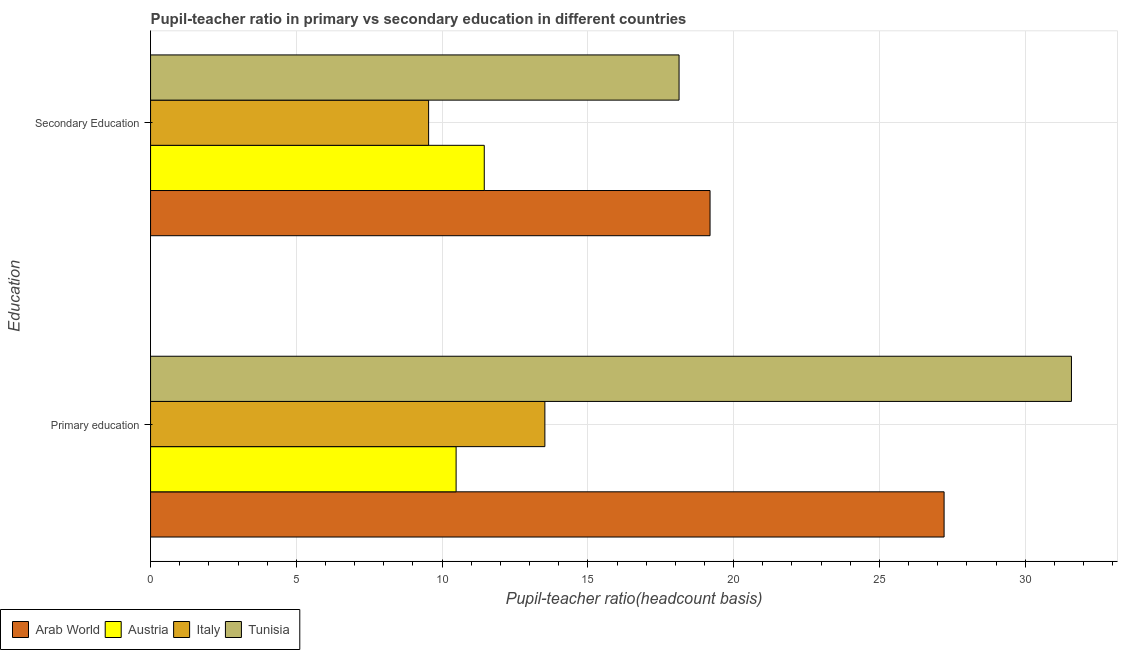How many different coloured bars are there?
Your answer should be very brief. 4. How many groups of bars are there?
Ensure brevity in your answer.  2. Are the number of bars per tick equal to the number of legend labels?
Provide a succinct answer. Yes. Are the number of bars on each tick of the Y-axis equal?
Make the answer very short. Yes. What is the label of the 2nd group of bars from the top?
Ensure brevity in your answer.  Primary education. What is the pupil-teacher ratio in primary education in Arab World?
Offer a terse response. 27.22. Across all countries, what is the maximum pupil teacher ratio on secondary education?
Offer a very short reply. 19.19. Across all countries, what is the minimum pupil-teacher ratio in primary education?
Provide a succinct answer. 10.48. In which country was the pupil teacher ratio on secondary education maximum?
Keep it short and to the point. Arab World. In which country was the pupil-teacher ratio in primary education minimum?
Your answer should be very brief. Austria. What is the total pupil-teacher ratio in primary education in the graph?
Offer a very short reply. 82.81. What is the difference between the pupil-teacher ratio in primary education in Austria and that in Tunisia?
Your answer should be compact. -21.11. What is the difference between the pupil-teacher ratio in primary education in Arab World and the pupil teacher ratio on secondary education in Austria?
Provide a succinct answer. 15.77. What is the average pupil teacher ratio on secondary education per country?
Offer a very short reply. 14.58. What is the difference between the pupil-teacher ratio in primary education and pupil teacher ratio on secondary education in Arab World?
Offer a very short reply. 8.03. In how many countries, is the pupil teacher ratio on secondary education greater than 9 ?
Ensure brevity in your answer.  4. What is the ratio of the pupil-teacher ratio in primary education in Arab World to that in Italy?
Offer a terse response. 2.01. Is the pupil teacher ratio on secondary education in Italy less than that in Austria?
Your response must be concise. Yes. In how many countries, is the pupil-teacher ratio in primary education greater than the average pupil-teacher ratio in primary education taken over all countries?
Provide a succinct answer. 2. What does the 2nd bar from the top in Primary education represents?
Ensure brevity in your answer.  Italy. What does the 4th bar from the bottom in Primary education represents?
Your response must be concise. Tunisia. How many bars are there?
Give a very brief answer. 8. What is the difference between two consecutive major ticks on the X-axis?
Keep it short and to the point. 5. Are the values on the major ticks of X-axis written in scientific E-notation?
Your answer should be compact. No. Does the graph contain any zero values?
Your answer should be very brief. No. Where does the legend appear in the graph?
Provide a short and direct response. Bottom left. How many legend labels are there?
Offer a very short reply. 4. How are the legend labels stacked?
Offer a very short reply. Horizontal. What is the title of the graph?
Your answer should be very brief. Pupil-teacher ratio in primary vs secondary education in different countries. What is the label or title of the X-axis?
Your answer should be very brief. Pupil-teacher ratio(headcount basis). What is the label or title of the Y-axis?
Offer a terse response. Education. What is the Pupil-teacher ratio(headcount basis) in Arab World in Primary education?
Offer a terse response. 27.22. What is the Pupil-teacher ratio(headcount basis) of Austria in Primary education?
Offer a very short reply. 10.48. What is the Pupil-teacher ratio(headcount basis) of Italy in Primary education?
Your response must be concise. 13.52. What is the Pupil-teacher ratio(headcount basis) of Tunisia in Primary education?
Provide a short and direct response. 31.59. What is the Pupil-teacher ratio(headcount basis) of Arab World in Secondary Education?
Your answer should be compact. 19.19. What is the Pupil-teacher ratio(headcount basis) in Austria in Secondary Education?
Provide a short and direct response. 11.45. What is the Pupil-teacher ratio(headcount basis) of Italy in Secondary Education?
Your answer should be compact. 9.54. What is the Pupil-teacher ratio(headcount basis) in Tunisia in Secondary Education?
Give a very brief answer. 18.13. Across all Education, what is the maximum Pupil-teacher ratio(headcount basis) in Arab World?
Provide a short and direct response. 27.22. Across all Education, what is the maximum Pupil-teacher ratio(headcount basis) in Austria?
Offer a very short reply. 11.45. Across all Education, what is the maximum Pupil-teacher ratio(headcount basis) in Italy?
Make the answer very short. 13.52. Across all Education, what is the maximum Pupil-teacher ratio(headcount basis) of Tunisia?
Your answer should be very brief. 31.59. Across all Education, what is the minimum Pupil-teacher ratio(headcount basis) of Arab World?
Your answer should be compact. 19.19. Across all Education, what is the minimum Pupil-teacher ratio(headcount basis) of Austria?
Your answer should be very brief. 10.48. Across all Education, what is the minimum Pupil-teacher ratio(headcount basis) in Italy?
Give a very brief answer. 9.54. Across all Education, what is the minimum Pupil-teacher ratio(headcount basis) in Tunisia?
Provide a short and direct response. 18.13. What is the total Pupil-teacher ratio(headcount basis) of Arab World in the graph?
Your answer should be very brief. 46.41. What is the total Pupil-teacher ratio(headcount basis) in Austria in the graph?
Give a very brief answer. 21.93. What is the total Pupil-teacher ratio(headcount basis) of Italy in the graph?
Your answer should be compact. 23.06. What is the total Pupil-teacher ratio(headcount basis) of Tunisia in the graph?
Provide a short and direct response. 49.71. What is the difference between the Pupil-teacher ratio(headcount basis) of Arab World in Primary education and that in Secondary Education?
Your response must be concise. 8.03. What is the difference between the Pupil-teacher ratio(headcount basis) of Austria in Primary education and that in Secondary Education?
Give a very brief answer. -0.97. What is the difference between the Pupil-teacher ratio(headcount basis) in Italy in Primary education and that in Secondary Education?
Provide a succinct answer. 3.99. What is the difference between the Pupil-teacher ratio(headcount basis) in Tunisia in Primary education and that in Secondary Education?
Your answer should be very brief. 13.46. What is the difference between the Pupil-teacher ratio(headcount basis) in Arab World in Primary education and the Pupil-teacher ratio(headcount basis) in Austria in Secondary Education?
Your answer should be compact. 15.77. What is the difference between the Pupil-teacher ratio(headcount basis) of Arab World in Primary education and the Pupil-teacher ratio(headcount basis) of Italy in Secondary Education?
Your response must be concise. 17.68. What is the difference between the Pupil-teacher ratio(headcount basis) of Arab World in Primary education and the Pupil-teacher ratio(headcount basis) of Tunisia in Secondary Education?
Your response must be concise. 9.09. What is the difference between the Pupil-teacher ratio(headcount basis) in Austria in Primary education and the Pupil-teacher ratio(headcount basis) in Italy in Secondary Education?
Provide a short and direct response. 0.94. What is the difference between the Pupil-teacher ratio(headcount basis) in Austria in Primary education and the Pupil-teacher ratio(headcount basis) in Tunisia in Secondary Education?
Make the answer very short. -7.65. What is the difference between the Pupil-teacher ratio(headcount basis) of Italy in Primary education and the Pupil-teacher ratio(headcount basis) of Tunisia in Secondary Education?
Provide a short and direct response. -4.6. What is the average Pupil-teacher ratio(headcount basis) of Arab World per Education?
Make the answer very short. 23.2. What is the average Pupil-teacher ratio(headcount basis) in Austria per Education?
Ensure brevity in your answer.  10.96. What is the average Pupil-teacher ratio(headcount basis) in Italy per Education?
Offer a terse response. 11.53. What is the average Pupil-teacher ratio(headcount basis) of Tunisia per Education?
Offer a terse response. 24.86. What is the difference between the Pupil-teacher ratio(headcount basis) of Arab World and Pupil-teacher ratio(headcount basis) of Austria in Primary education?
Your response must be concise. 16.74. What is the difference between the Pupil-teacher ratio(headcount basis) in Arab World and Pupil-teacher ratio(headcount basis) in Italy in Primary education?
Your answer should be compact. 13.69. What is the difference between the Pupil-teacher ratio(headcount basis) of Arab World and Pupil-teacher ratio(headcount basis) of Tunisia in Primary education?
Give a very brief answer. -4.37. What is the difference between the Pupil-teacher ratio(headcount basis) of Austria and Pupil-teacher ratio(headcount basis) of Italy in Primary education?
Offer a very short reply. -3.04. What is the difference between the Pupil-teacher ratio(headcount basis) of Austria and Pupil-teacher ratio(headcount basis) of Tunisia in Primary education?
Keep it short and to the point. -21.11. What is the difference between the Pupil-teacher ratio(headcount basis) of Italy and Pupil-teacher ratio(headcount basis) of Tunisia in Primary education?
Provide a succinct answer. -18.06. What is the difference between the Pupil-teacher ratio(headcount basis) in Arab World and Pupil-teacher ratio(headcount basis) in Austria in Secondary Education?
Provide a succinct answer. 7.74. What is the difference between the Pupil-teacher ratio(headcount basis) in Arab World and Pupil-teacher ratio(headcount basis) in Italy in Secondary Education?
Offer a terse response. 9.65. What is the difference between the Pupil-teacher ratio(headcount basis) in Arab World and Pupil-teacher ratio(headcount basis) in Tunisia in Secondary Education?
Provide a succinct answer. 1.06. What is the difference between the Pupil-teacher ratio(headcount basis) of Austria and Pupil-teacher ratio(headcount basis) of Italy in Secondary Education?
Ensure brevity in your answer.  1.91. What is the difference between the Pupil-teacher ratio(headcount basis) of Austria and Pupil-teacher ratio(headcount basis) of Tunisia in Secondary Education?
Make the answer very short. -6.68. What is the difference between the Pupil-teacher ratio(headcount basis) in Italy and Pupil-teacher ratio(headcount basis) in Tunisia in Secondary Education?
Offer a very short reply. -8.59. What is the ratio of the Pupil-teacher ratio(headcount basis) in Arab World in Primary education to that in Secondary Education?
Provide a succinct answer. 1.42. What is the ratio of the Pupil-teacher ratio(headcount basis) of Austria in Primary education to that in Secondary Education?
Provide a short and direct response. 0.92. What is the ratio of the Pupil-teacher ratio(headcount basis) in Italy in Primary education to that in Secondary Education?
Offer a very short reply. 1.42. What is the ratio of the Pupil-teacher ratio(headcount basis) in Tunisia in Primary education to that in Secondary Education?
Your answer should be compact. 1.74. What is the difference between the highest and the second highest Pupil-teacher ratio(headcount basis) in Arab World?
Provide a succinct answer. 8.03. What is the difference between the highest and the second highest Pupil-teacher ratio(headcount basis) in Austria?
Offer a very short reply. 0.97. What is the difference between the highest and the second highest Pupil-teacher ratio(headcount basis) in Italy?
Offer a terse response. 3.99. What is the difference between the highest and the second highest Pupil-teacher ratio(headcount basis) of Tunisia?
Make the answer very short. 13.46. What is the difference between the highest and the lowest Pupil-teacher ratio(headcount basis) of Arab World?
Keep it short and to the point. 8.03. What is the difference between the highest and the lowest Pupil-teacher ratio(headcount basis) in Austria?
Provide a short and direct response. 0.97. What is the difference between the highest and the lowest Pupil-teacher ratio(headcount basis) in Italy?
Provide a short and direct response. 3.99. What is the difference between the highest and the lowest Pupil-teacher ratio(headcount basis) in Tunisia?
Your answer should be very brief. 13.46. 